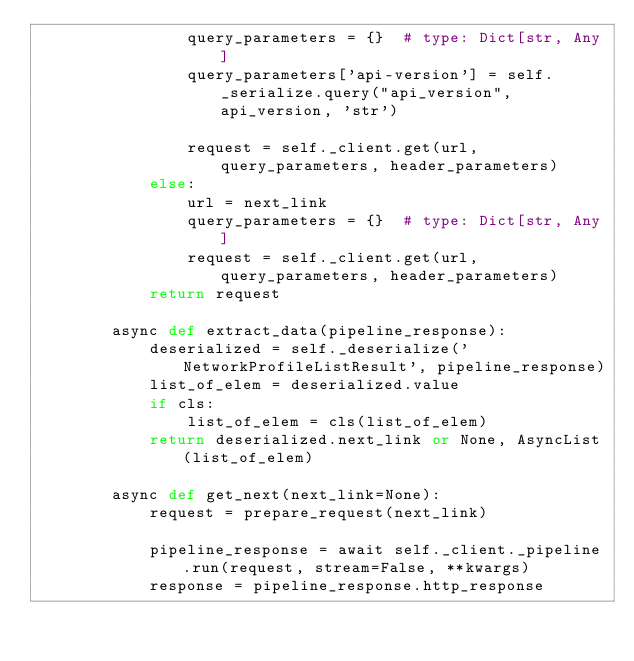Convert code to text. <code><loc_0><loc_0><loc_500><loc_500><_Python_>                query_parameters = {}  # type: Dict[str, Any]
                query_parameters['api-version'] = self._serialize.query("api_version", api_version, 'str')

                request = self._client.get(url, query_parameters, header_parameters)
            else:
                url = next_link
                query_parameters = {}  # type: Dict[str, Any]
                request = self._client.get(url, query_parameters, header_parameters)
            return request

        async def extract_data(pipeline_response):
            deserialized = self._deserialize('NetworkProfileListResult', pipeline_response)
            list_of_elem = deserialized.value
            if cls:
                list_of_elem = cls(list_of_elem)
            return deserialized.next_link or None, AsyncList(list_of_elem)

        async def get_next(next_link=None):
            request = prepare_request(next_link)

            pipeline_response = await self._client._pipeline.run(request, stream=False, **kwargs)
            response = pipeline_response.http_response
</code> 